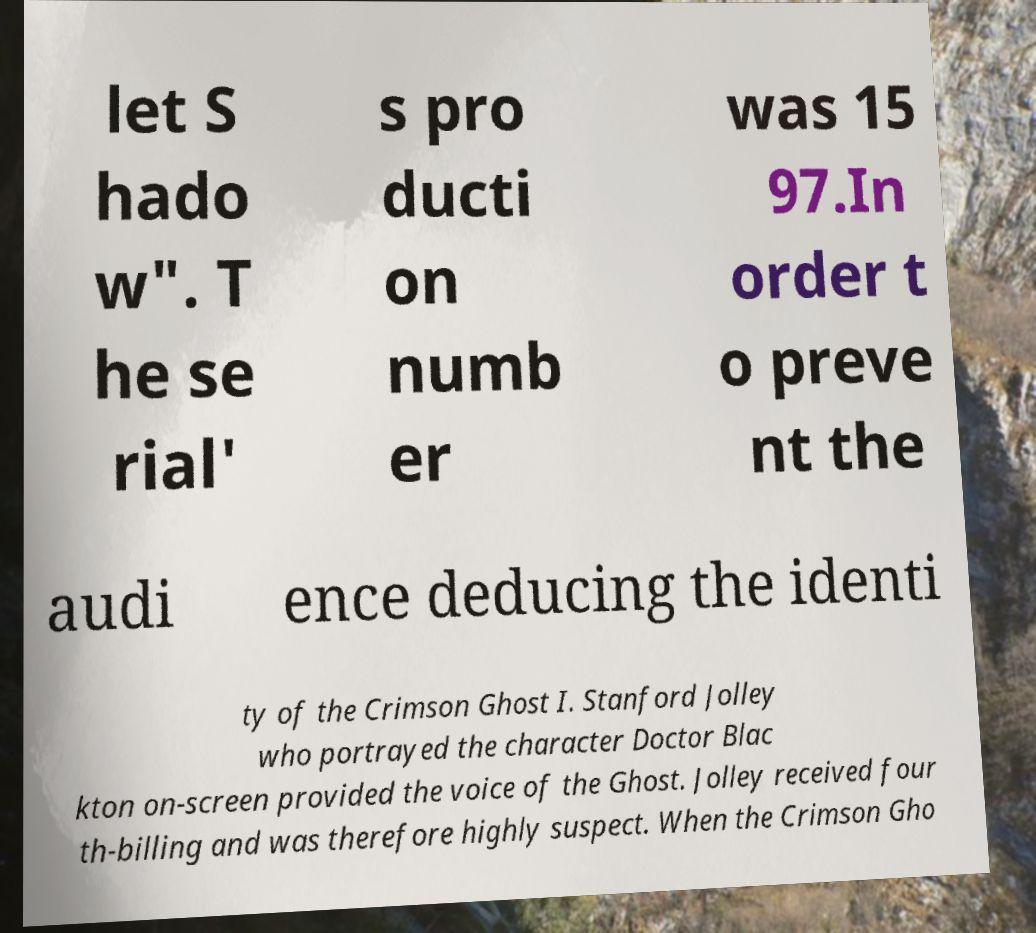Please read and relay the text visible in this image. What does it say? let S hado w". T he se rial' s pro ducti on numb er was 15 97.In order t o preve nt the audi ence deducing the identi ty of the Crimson Ghost I. Stanford Jolley who portrayed the character Doctor Blac kton on-screen provided the voice of the Ghost. Jolley received four th-billing and was therefore highly suspect. When the Crimson Gho 